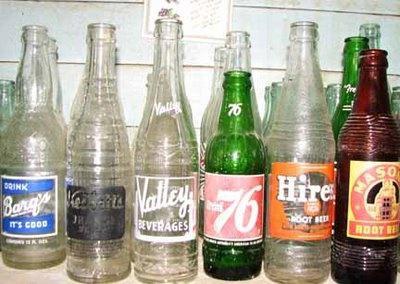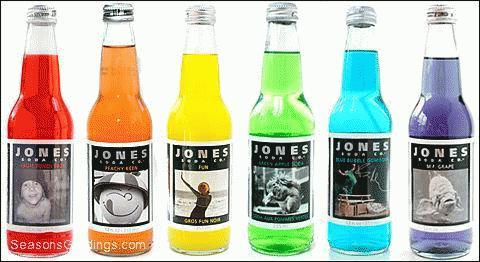The first image is the image on the left, the second image is the image on the right. For the images displayed, is the sentence "The left image features a row of at least six empty soda bottles without lids, and the right image shows exactly six filled bottles of soda with caps on." factually correct? Answer yes or no. Yes. The first image is the image on the left, the second image is the image on the right. Examine the images to the left and right. Is the description "There are exactly six bottles in the right image." accurate? Answer yes or no. Yes. 